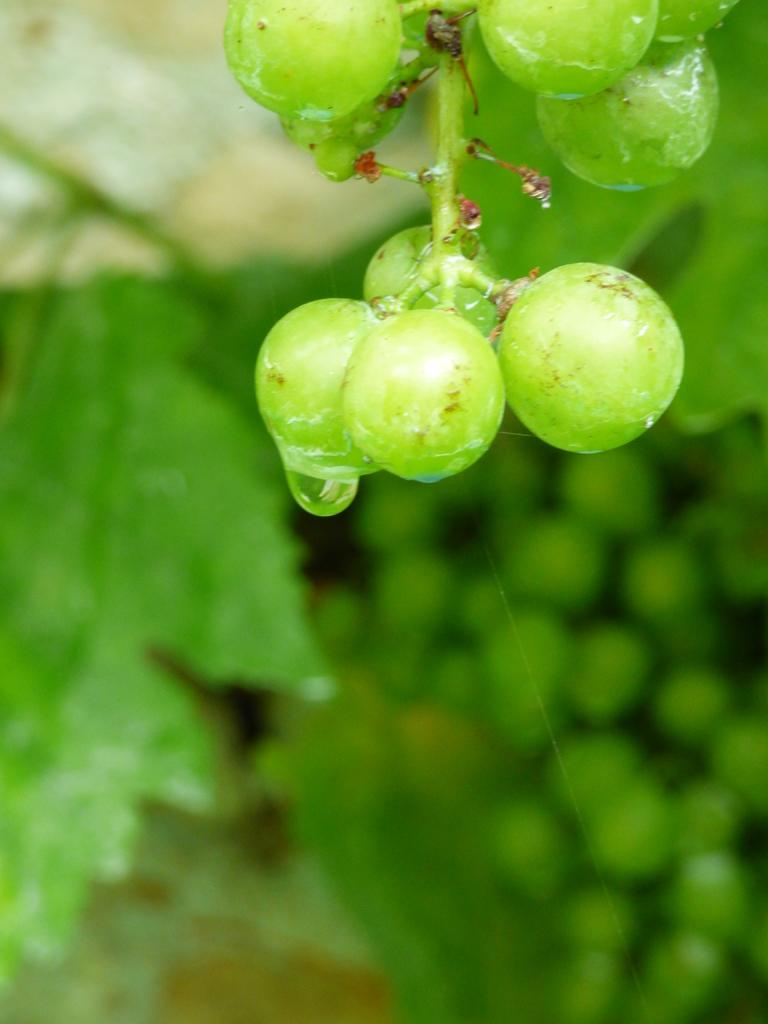What type of food is depicted in the image? There are fruits in the image that resemble grapes. What color is present at the bottom of the image? The bottom of the image is green in color. How would you describe the overall clarity of the image? The image is blurred. What type of ice can be seen melting on the doll in the image? There is no ice or doll present in the image; it only features fruits that resemble grapes and a green background. Can you describe the skateboarding skills of the person in the image? There is no person or skateboarding activity depicted in the image. 